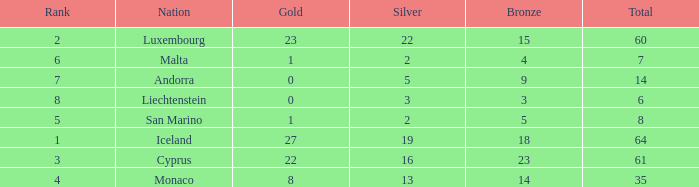Where does Iceland rank with under 19 silvers? None. 